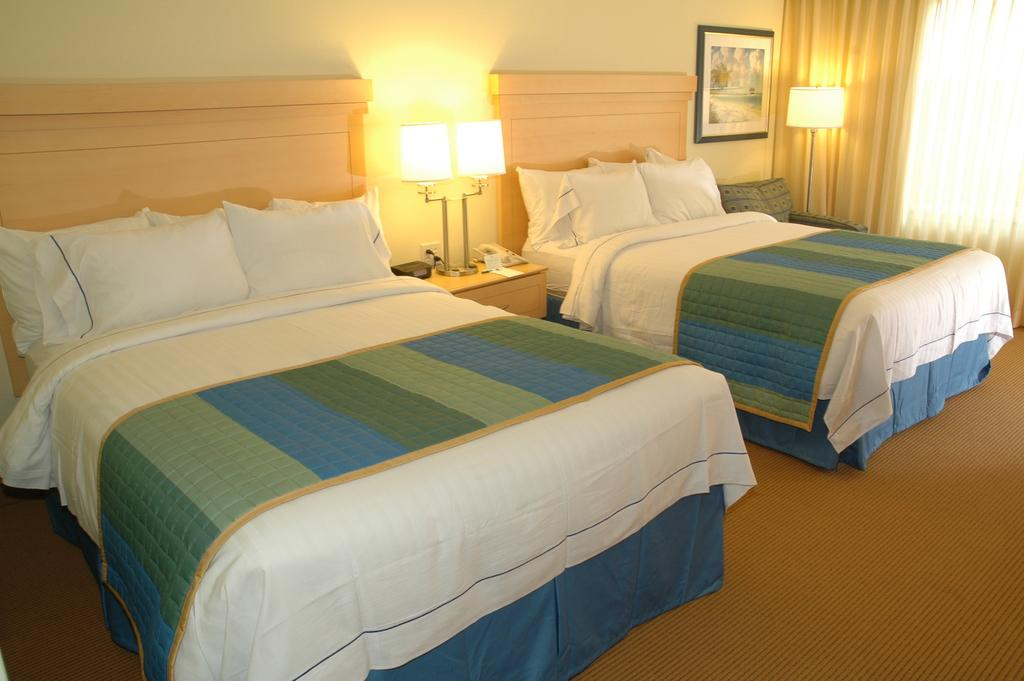What type of furniture is present in the image? There are beds, tables, and a picture on the wall in the image. What items can be found on the beds? There are pillows and bed-sheets on the beds in the image. What is the purpose of the lamps in the image? The lamps on the tables provide light in the image. What type of window treatment is present in the image? There is a curtain in the image. How does the transport system work in the image? There is no transport system present in the image; it features a bedroom setting with beds, tables, lamps, and a curtain. What type of nail is used to hang the picture on the wall? There is no nail visible in the image, and the picture is not mentioned to be hung on the wall. 